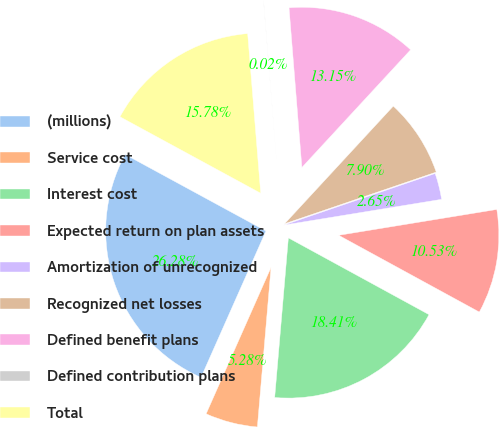<chart> <loc_0><loc_0><loc_500><loc_500><pie_chart><fcel>(millions)<fcel>Service cost<fcel>Interest cost<fcel>Expected return on plan assets<fcel>Amortization of unrecognized<fcel>Recognized net losses<fcel>Defined benefit plans<fcel>Defined contribution plans<fcel>Total<nl><fcel>26.28%<fcel>5.28%<fcel>18.41%<fcel>10.53%<fcel>2.65%<fcel>7.9%<fcel>13.15%<fcel>0.02%<fcel>15.78%<nl></chart> 